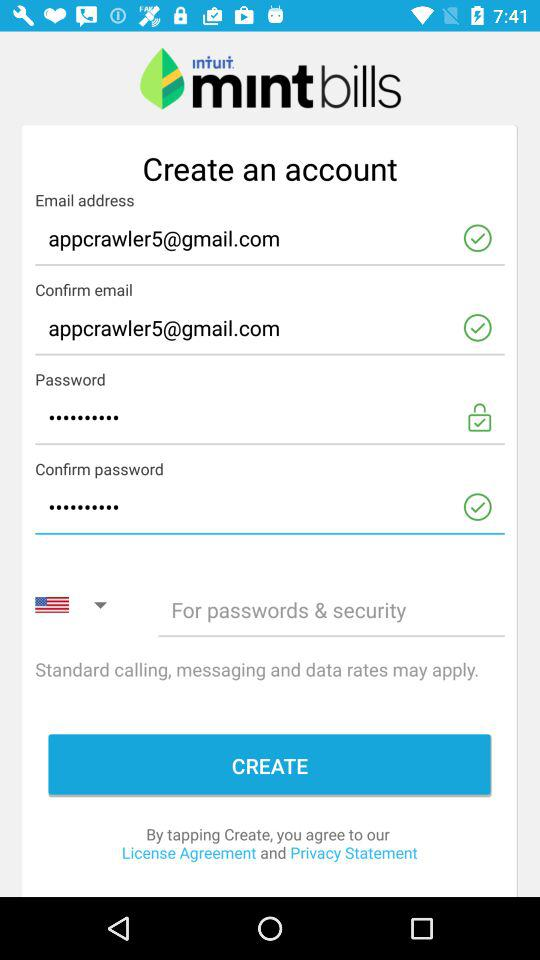What is the written password?
When the provided information is insufficient, respond with <no answer>. <no answer> 